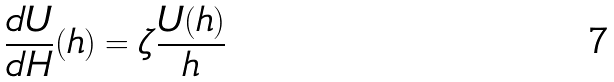<formula> <loc_0><loc_0><loc_500><loc_500>\frac { d U } { d H } ( h ) = \zeta \frac { U ( h ) } { h }</formula> 